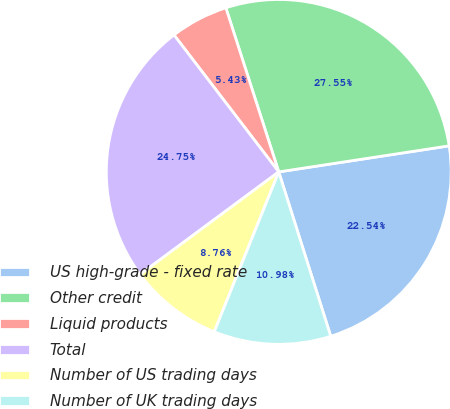Convert chart to OTSL. <chart><loc_0><loc_0><loc_500><loc_500><pie_chart><fcel>US high-grade - fixed rate<fcel>Other credit<fcel>Liquid products<fcel>Total<fcel>Number of US trading days<fcel>Number of UK trading days<nl><fcel>22.54%<fcel>27.55%<fcel>5.43%<fcel>24.75%<fcel>8.76%<fcel>10.98%<nl></chart> 